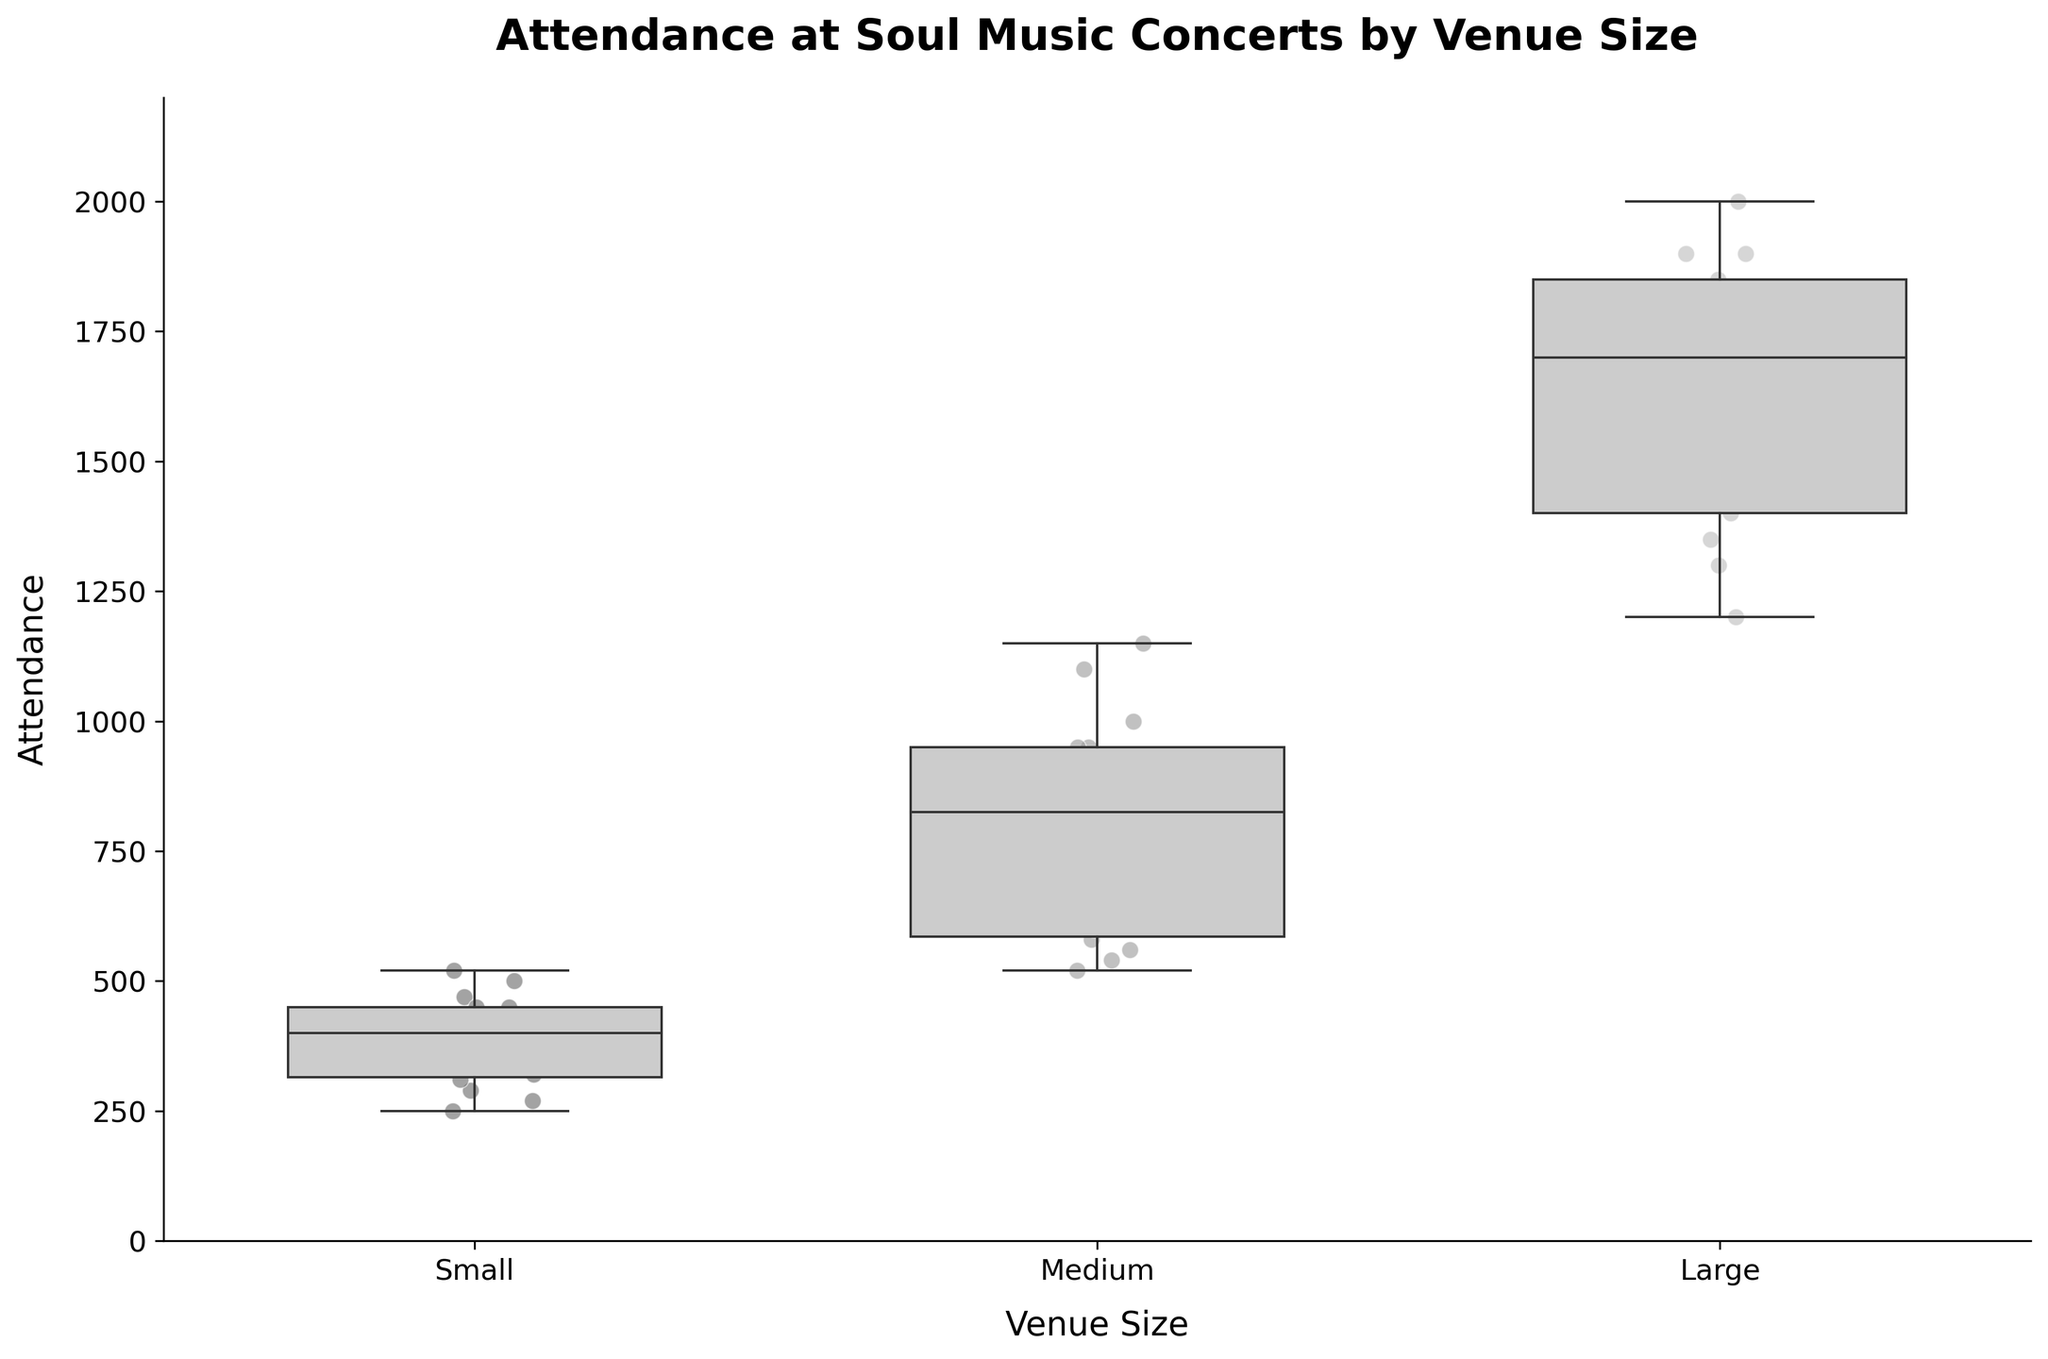What is the title of the figure? The title of the figure is typically located at the top and is often the largest text. It provides a concise description of the figure's content.
Answer: Attendance at Soul Music Concerts by Venue Size What are the labels for the x-axis and y-axis? The labels for the x-axis and y-axis indicate the variables being plotted. They are typically found along the axes themselves. The x-axis label is "Venue Size," and the y-axis label is "Attendance."
Answer: Venue Size, Attendance How many categories of venue sizes are presented in the box plot? By examining the x-axis, you can see the different categories or groups that are present. There are three categories: Small, Medium, and Large.
Answer: Three Which venue size has the highest median attendance? To find the highest median, look at the line inside the box for each venue size; the one with the highest median will have the highest horizontal line inside the box.
Answer: Large What is the approximate range of attendance for small venues? The range can be determined by looking at the bottom and top of the whiskers of the "Small" category box plot. The minimum attendance is around 250 and the maximum is around 450.
Answer: 250 to 450 Which venue size shows the most variability in attendance? Variability can be assessed by the height of the box and the length of the whiskers. The box plot with the largest box and longest whiskers shows the most variability.
Answer: Large What is the minimum attendance value for medium venues? The minimum value can be found at the bottom of the whiskers of the "Medium" venue size box plot.
Answer: 520 How does the median attendance of medium venues compare to small venues? Compare the median lines inside the boxes of "Small" and "Medium" venue sizes. The median for medium venues is higher.
Answer: Higher Which venue size often holds more attendees? Observing the box plot and scatter points for each venue size, we can see that "Large" venues generally have higher attendance values.
Answer: Large Are there any noticeable outliers in the data? In a box plot, outliers are often represented as individual points outside the whiskers. There are no points outside the whiskers in this plot, implying there are no noticeable outliers.
Answer: No 